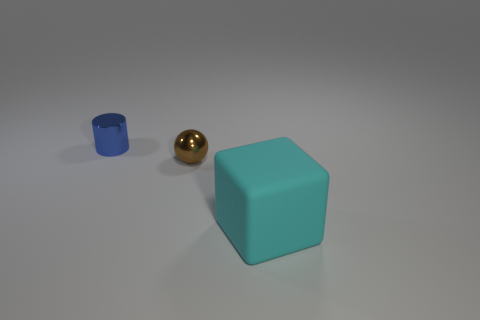Add 3 small spheres. How many objects exist? 6 Subtract all cubes. How many objects are left? 2 Subtract 0 red cubes. How many objects are left? 3 Subtract all tiny yellow rubber cubes. Subtract all cylinders. How many objects are left? 2 Add 3 small metallic cylinders. How many small metallic cylinders are left? 4 Add 2 big blue shiny things. How many big blue shiny things exist? 2 